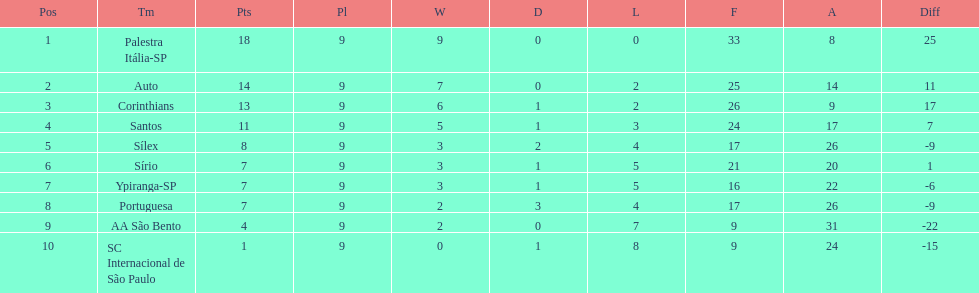Which team was the only team that was undefeated? Palestra Itália-SP. 